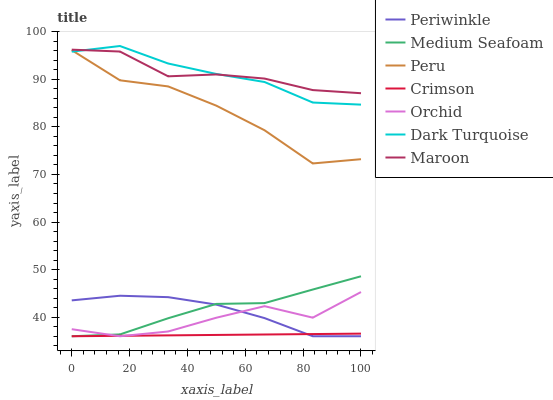Does Crimson have the minimum area under the curve?
Answer yes or no. Yes. Does Maroon have the maximum area under the curve?
Answer yes or no. Yes. Does Periwinkle have the minimum area under the curve?
Answer yes or no. No. Does Periwinkle have the maximum area under the curve?
Answer yes or no. No. Is Crimson the smoothest?
Answer yes or no. Yes. Is Peru the roughest?
Answer yes or no. Yes. Is Maroon the smoothest?
Answer yes or no. No. Is Maroon the roughest?
Answer yes or no. No. Does Maroon have the lowest value?
Answer yes or no. No. Does Dark Turquoise have the highest value?
Answer yes or no. Yes. Does Maroon have the highest value?
Answer yes or no. No. Is Periwinkle less than Maroon?
Answer yes or no. Yes. Is Maroon greater than Medium Seafoam?
Answer yes or no. Yes. Does Crimson intersect Periwinkle?
Answer yes or no. Yes. Is Crimson less than Periwinkle?
Answer yes or no. No. Is Crimson greater than Periwinkle?
Answer yes or no. No. Does Periwinkle intersect Maroon?
Answer yes or no. No. 